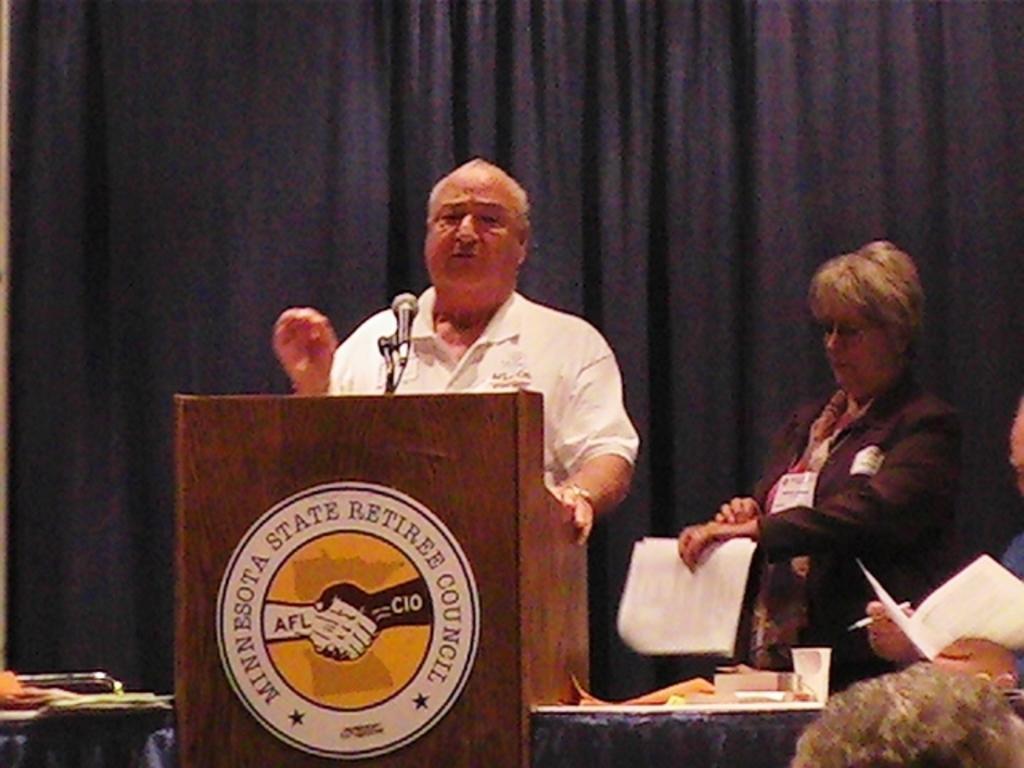Could you give a brief overview of what you see in this image? This is a picture from a meeting. In the center of the picture there is a person talking in front of the podium. On the right there is a woman standing, holding papers. On the right there is a desk, on the desk there are books, papers and cup. On the right there is a person holding paper and pen. In the background there is a black curtain. On the left there is a desk, on the desk there are papers. 